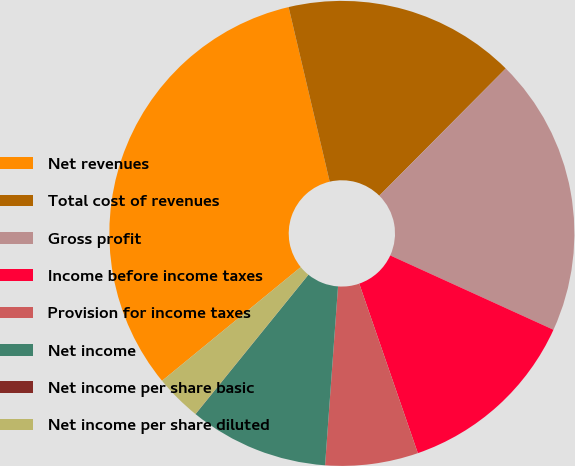Convert chart to OTSL. <chart><loc_0><loc_0><loc_500><loc_500><pie_chart><fcel>Net revenues<fcel>Total cost of revenues<fcel>Gross profit<fcel>Income before income taxes<fcel>Provision for income taxes<fcel>Net income<fcel>Net income per share basic<fcel>Net income per share diluted<nl><fcel>32.25%<fcel>16.13%<fcel>19.35%<fcel>12.9%<fcel>6.45%<fcel>9.68%<fcel>0.01%<fcel>3.23%<nl></chart> 